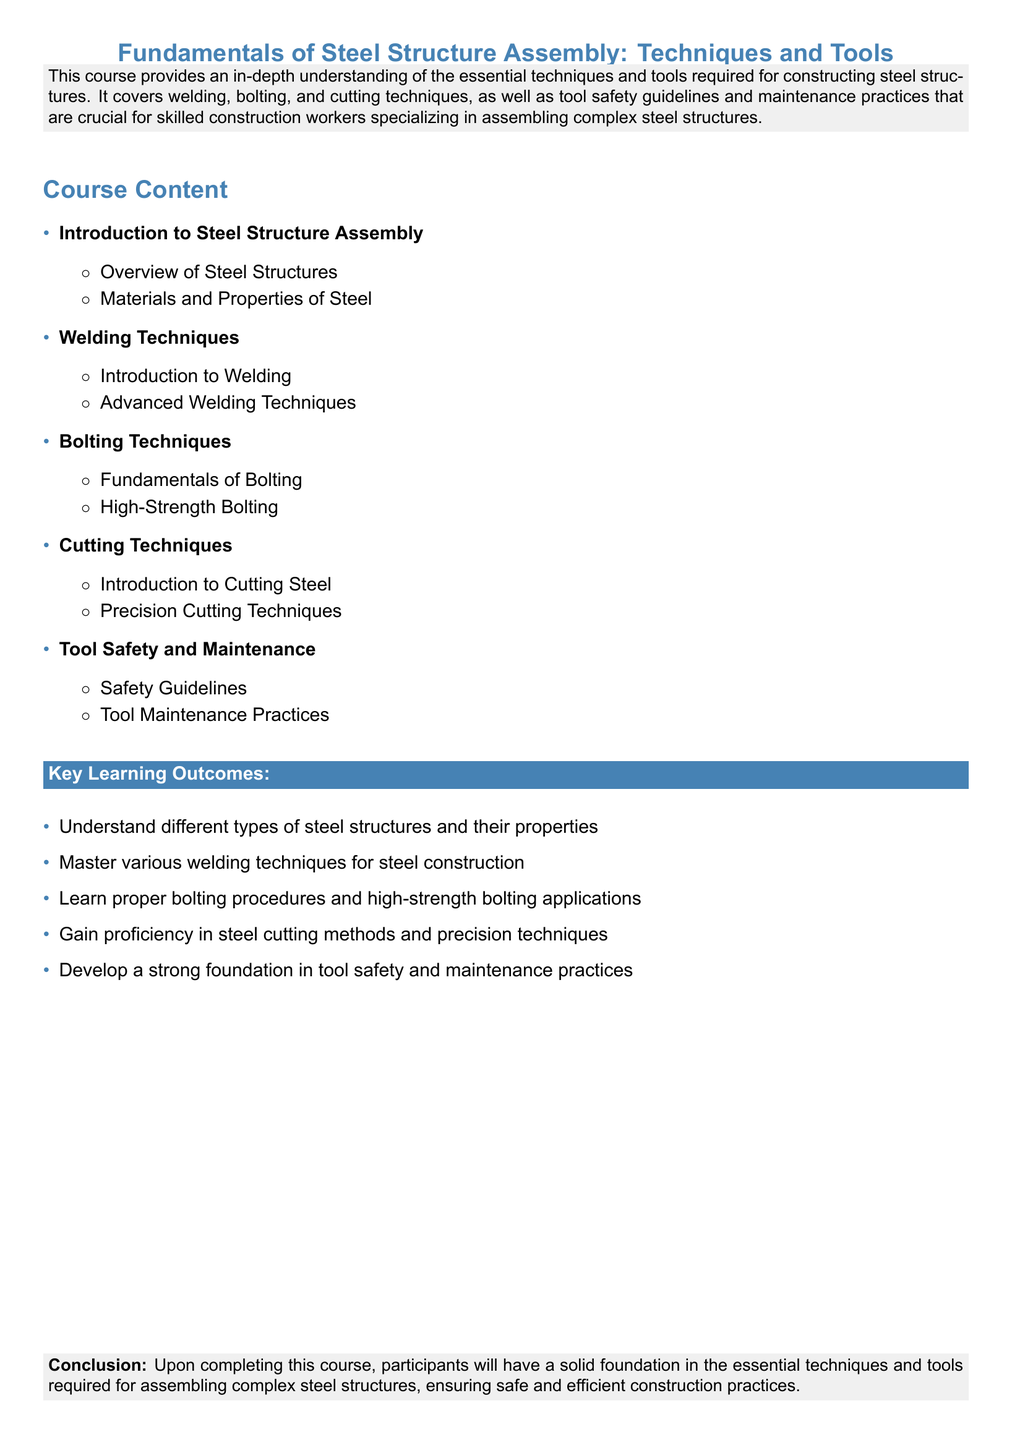What is the course title? The course title is the main heading of the document, summarizing the subject matter of the syllabus.
Answer: Fundamentals of Steel Structure Assembly: Techniques and Tools What does the course cover? The document provides a brief description that outlines the main topics to be covered in the course.
Answer: Essential techniques and tools required for constructing steel structures How many sections are in the course content? The sections listed in the course content detail the various areas of learning within the course.
Answer: Five What is one of the Key Learning Outcomes? The Key Learning Outcomes list the skills and knowledge participants will gain upon course completion.
Answer: Understand different types of steel structures and their properties What is included in Tool Safety and Maintenance? This refers to a specific section where safety and maintenance practices are discussed as part of the training.
Answer: Safety Guidelines What type of welding is introduced in this course? The course content specifies foundational skills introduced to participants regarding welding techniques.
Answer: Introduction to Welding What is the focus of the Cutting Techniques section? The Cutting Techniques section indicates what participants will learn regarding cutting steel.
Answer: Precision Cutting Techniques What is the purpose of the document? The document serves as a syllabus for a specific training course, defining the course's recognition and expectations.
Answer: Provide an in-depth understanding of essential techniques and tools What is the color used for the course title? This question asks about the visual style and design element present in the syllabus.
Answer: Steelblue 